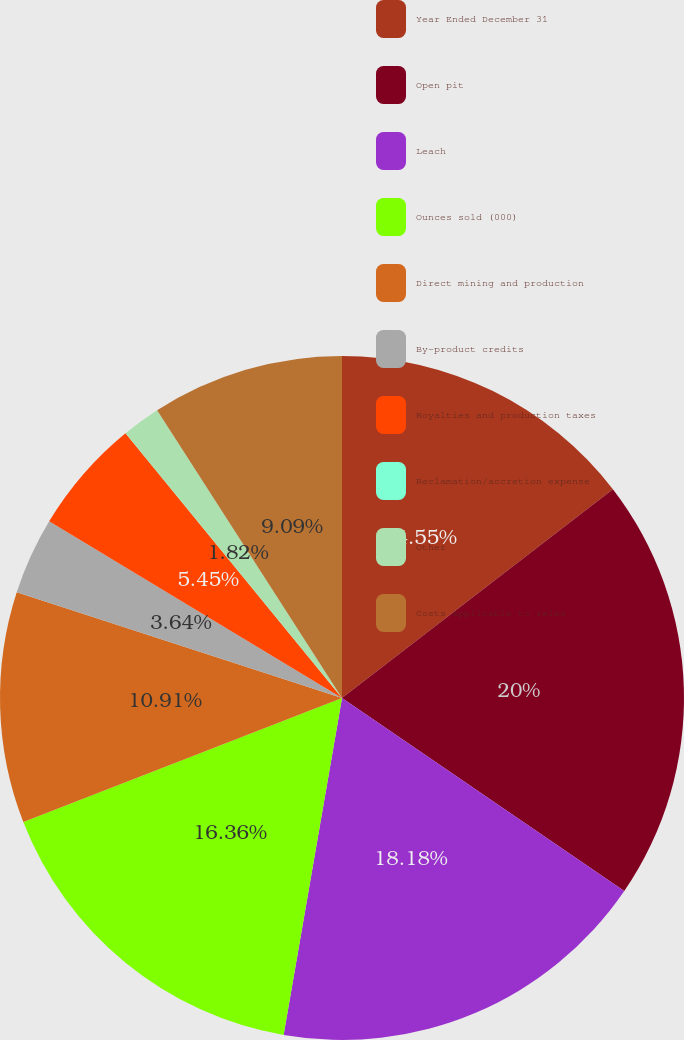Convert chart. <chart><loc_0><loc_0><loc_500><loc_500><pie_chart><fcel>Year Ended December 31<fcel>Open pit<fcel>Leach<fcel>Ounces sold (000)<fcel>Direct mining and production<fcel>By-product credits<fcel>Royalties and production taxes<fcel>Reclamation/accretion expense<fcel>Other<fcel>Costs applicable to sales<nl><fcel>14.55%<fcel>20.0%<fcel>18.18%<fcel>16.36%<fcel>10.91%<fcel>3.64%<fcel>5.45%<fcel>0.0%<fcel>1.82%<fcel>9.09%<nl></chart> 